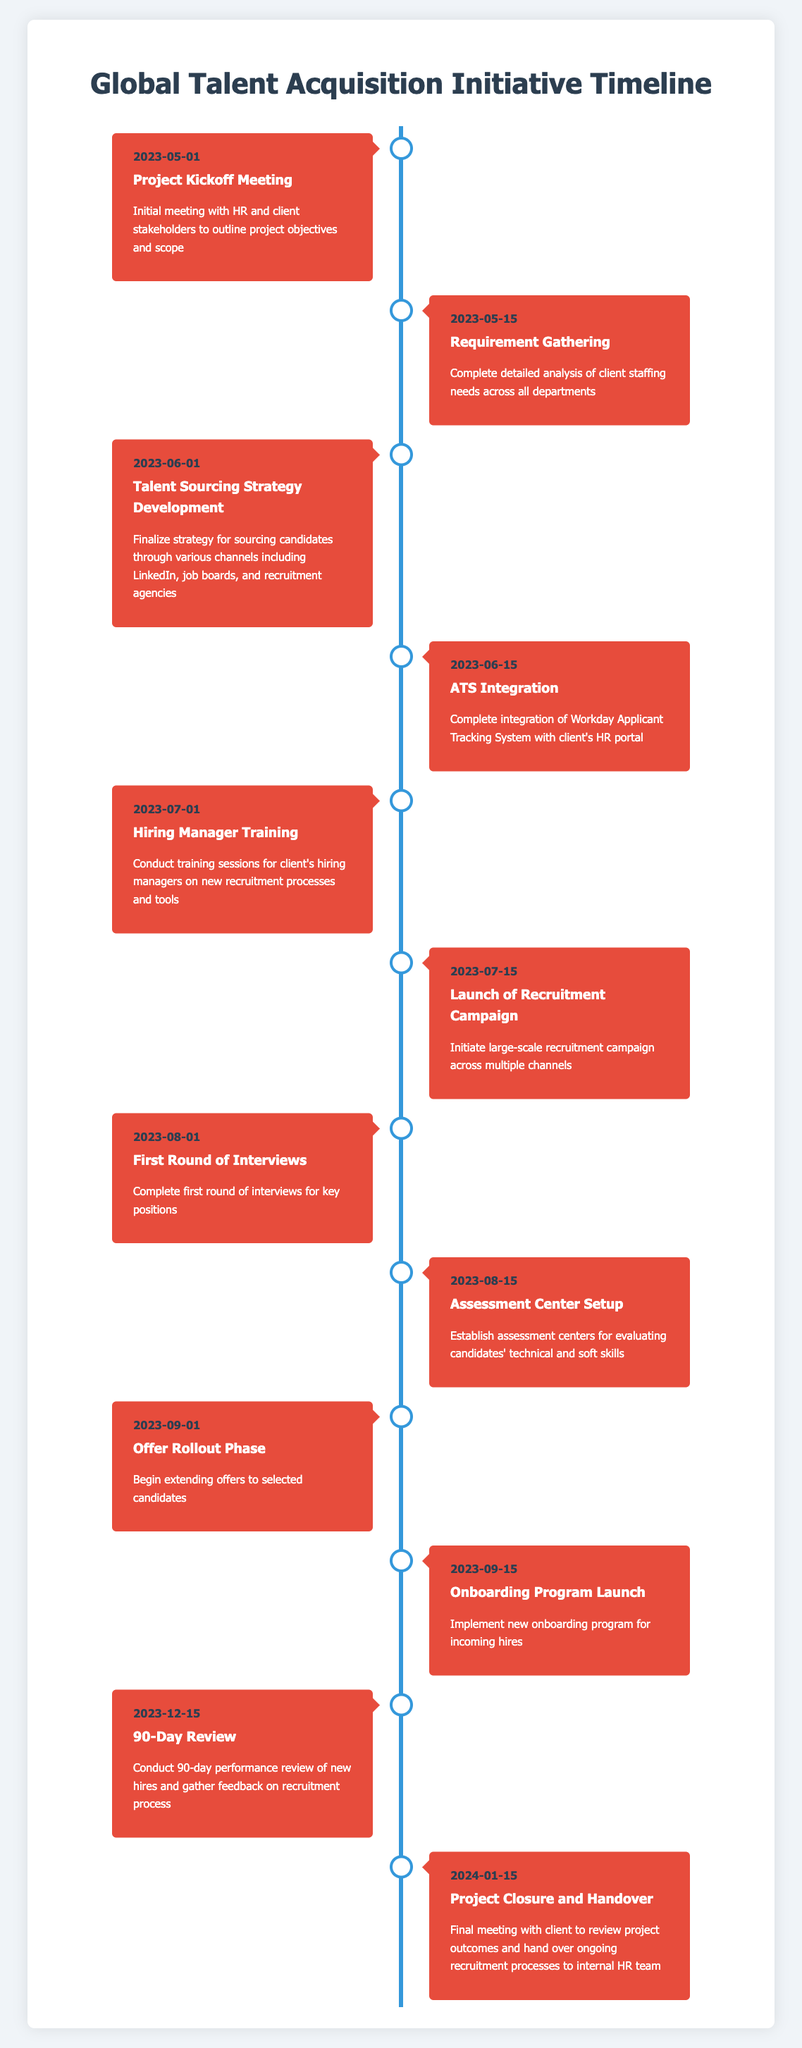What is the date of the Project Kickoff Meeting? The Project Kickoff Meeting is listed as the first milestone in the timeline with the date provided next to it. The date associated with this milestone is May 1, 2023.
Answer: May 1, 2023 How many milestones are scheduled before the Launch of Recruitment Campaign? The Launch of Recruitment Campaign is the sixth milestone on the timeline. To find the number of milestones before it, we count the milestones listed above it: Project Kickoff Meeting, Requirement Gathering, Talent Sourcing Strategy Development, ATS Integration, and Hiring Manager Training, which totals five milestones before the Launch of Recruitment Campaign.
Answer: 5 What is the milestone immediately following the Assessment Center Setup? Assessment Center Setup is noted as the eighth milestone on the timeline. The next milestone, which is the ninth one, is Offer Rollout Phase, scheduled for September 1, 2023.
Answer: Offer Rollout Phase Is there a milestone for a training session? The Hiring Manager Training milestone indicates that training sessions will be conducted for the client's hiring managers on new recruitment processes and tools. Therefore, there is indeed a milestone related to a training session.
Answer: Yes What is the time difference in days between the ATS Integration and Hiring Manager Training milestones? ATS Integration occurs on June 15, 2023, while Hiring Manager Training takes place on July 1, 2023. To determine the time difference, we can calculate the number of days between these two dates: June 15 to June 30 is 15 days, plus 1 day for July 1, totaling 16 days.
Answer: 16 days How many months are between the Launch of Recruitment Campaign and the Onboarding Program Launch? The Launch of Recruitment Campaign is scheduled for July 15, 2023, and the Onboarding Program Launch is on September 15, 2023. Counting the months from July to September gives us August as one month and September as the second month, with July being the partial month. Hence, the total is about two months.
Answer: 2 months What is the final milestone before the project closure date? The final milestone before the Project Closure and Handover, which is on January 15, 2024, is the 90-Day Review, scheduled for December 15, 2023. This can be identified by looking at the chronological order of the milestones listed.
Answer: 90-Day Review Which milestone indicates the integration of the ATS? The milestone indicating the integration of the ATS (Applicant Tracking System) is labeled "ATS Integration." According to the timeline, it is scheduled for June 15, 2023. Therefore, this milestone specifically refers to the integration of the ATS.
Answer: ATS Integration What activities are included in the Offer Rollout Phase? The Offer Rollout Phase is described as the period when extending offers to selected candidates begins. By looking at the description provided under this milestone, we can confirm that it primarily involves the activity of extending job offers to candidates identified for positions.
Answer: Extending job offers 